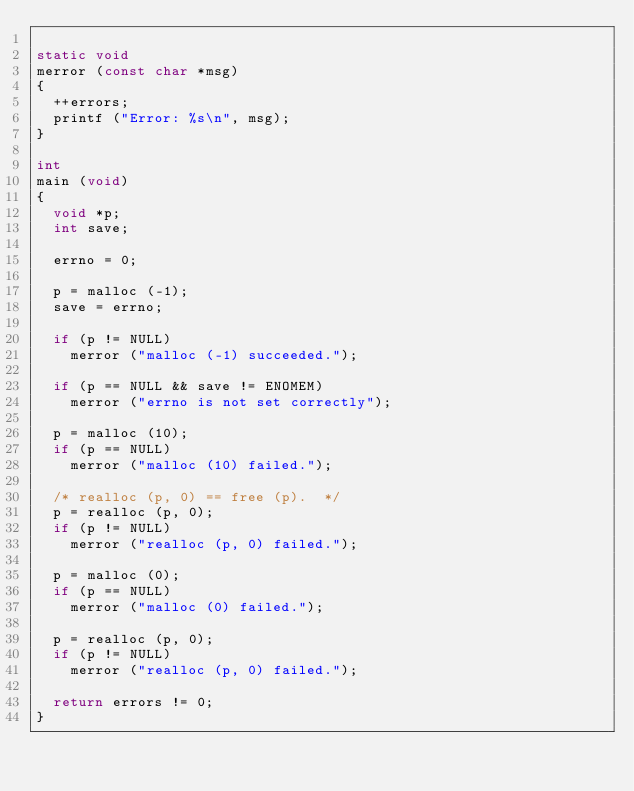<code> <loc_0><loc_0><loc_500><loc_500><_C_>
static void
merror (const char *msg)
{
  ++errors;
  printf ("Error: %s\n", msg);
}

int
main (void)
{
  void *p;
  int save;

  errno = 0;

  p = malloc (-1);
  save = errno;

  if (p != NULL)
    merror ("malloc (-1) succeeded.");

  if (p == NULL && save != ENOMEM)
    merror ("errno is not set correctly");

  p = malloc (10);
  if (p == NULL)
    merror ("malloc (10) failed.");

  /* realloc (p, 0) == free (p).  */
  p = realloc (p, 0);
  if (p != NULL)
    merror ("realloc (p, 0) failed.");

  p = malloc (0);
  if (p == NULL)
    merror ("malloc (0) failed.");

  p = realloc (p, 0);
  if (p != NULL)
    merror ("realloc (p, 0) failed.");

  return errors != 0;
}
</code> 